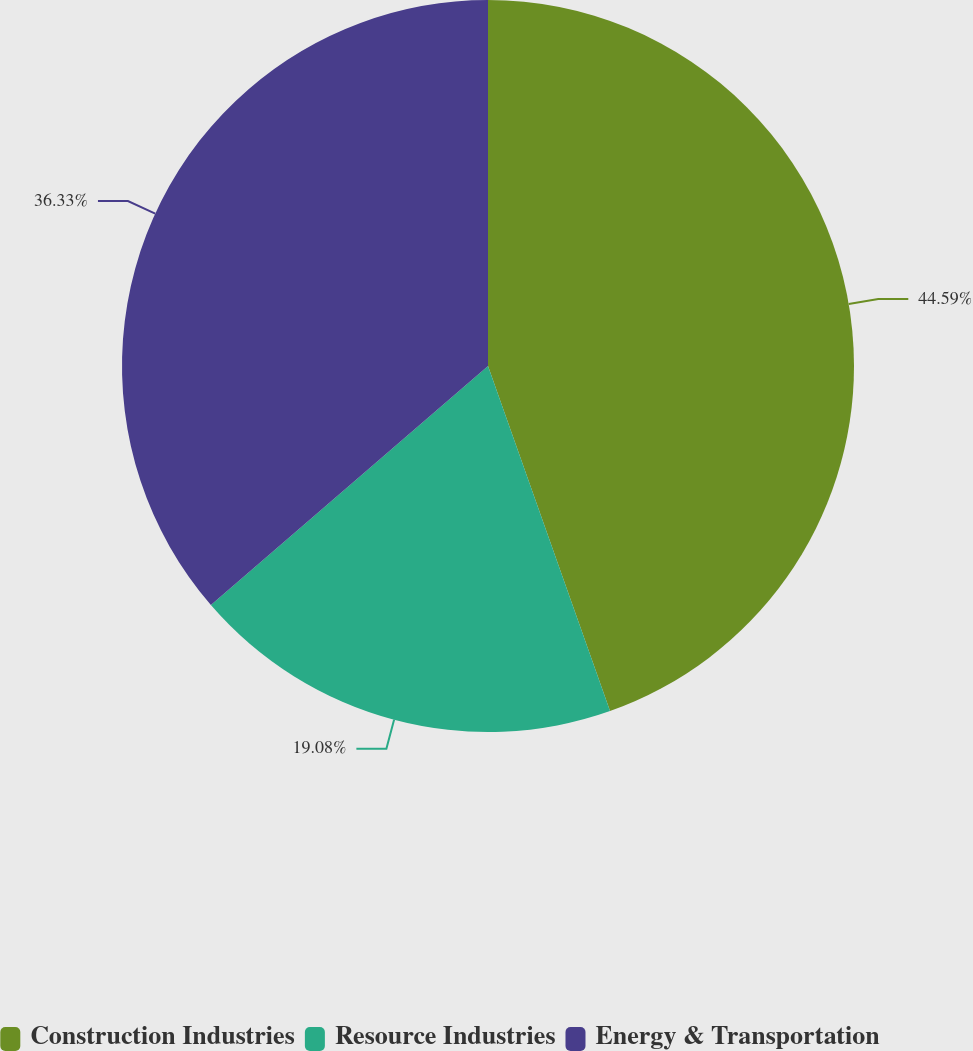<chart> <loc_0><loc_0><loc_500><loc_500><pie_chart><fcel>Construction Industries<fcel>Resource Industries<fcel>Energy & Transportation<nl><fcel>44.59%<fcel>19.08%<fcel>36.33%<nl></chart> 